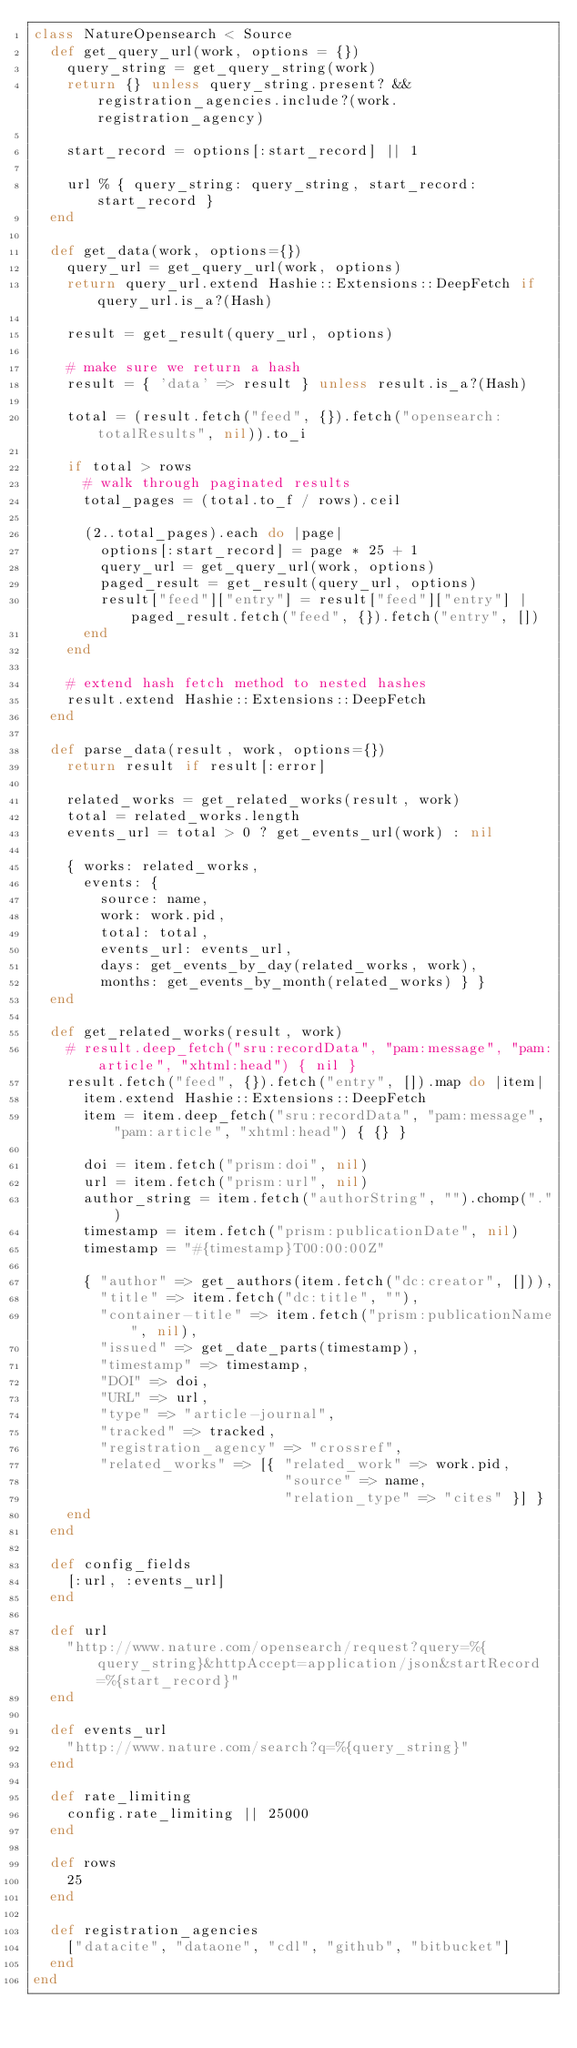Convert code to text. <code><loc_0><loc_0><loc_500><loc_500><_Ruby_>class NatureOpensearch < Source
  def get_query_url(work, options = {})
    query_string = get_query_string(work)
    return {} unless query_string.present? && registration_agencies.include?(work.registration_agency)

    start_record = options[:start_record] || 1

    url % { query_string: query_string, start_record: start_record }
  end

  def get_data(work, options={})
    query_url = get_query_url(work, options)
    return query_url.extend Hashie::Extensions::DeepFetch if query_url.is_a?(Hash)

    result = get_result(query_url, options)

    # make sure we return a hash
    result = { 'data' => result } unless result.is_a?(Hash)

    total = (result.fetch("feed", {}).fetch("opensearch:totalResults", nil)).to_i

    if total > rows
      # walk through paginated results
      total_pages = (total.to_f / rows).ceil

      (2..total_pages).each do |page|
        options[:start_record] = page * 25 + 1
        query_url = get_query_url(work, options)
        paged_result = get_result(query_url, options)
        result["feed"]["entry"] = result["feed"]["entry"] | paged_result.fetch("feed", {}).fetch("entry", [])
      end
    end

    # extend hash fetch method to nested hashes
    result.extend Hashie::Extensions::DeepFetch
  end

  def parse_data(result, work, options={})
    return result if result[:error]

    related_works = get_related_works(result, work)
    total = related_works.length
    events_url = total > 0 ? get_events_url(work) : nil

    { works: related_works,
      events: {
        source: name,
        work: work.pid,
        total: total,
        events_url: events_url,
        days: get_events_by_day(related_works, work),
        months: get_events_by_month(related_works) } }
  end

  def get_related_works(result, work)
    # result.deep_fetch("sru:recordData", "pam:message", "pam:article", "xhtml:head") { nil }
    result.fetch("feed", {}).fetch("entry", []).map do |item|
      item.extend Hashie::Extensions::DeepFetch
      item = item.deep_fetch("sru:recordData", "pam:message", "pam:article", "xhtml:head") { {} }

      doi = item.fetch("prism:doi", nil)
      url = item.fetch("prism:url", nil)
      author_string = item.fetch("authorString", "").chomp(".")
      timestamp = item.fetch("prism:publicationDate", nil)
      timestamp = "#{timestamp}T00:00:00Z"

      { "author" => get_authors(item.fetch("dc:creator", [])),
        "title" => item.fetch("dc:title", ""),
        "container-title" => item.fetch("prism:publicationName", nil),
        "issued" => get_date_parts(timestamp),
        "timestamp" => timestamp,
        "DOI" => doi,
        "URL" => url,
        "type" => "article-journal",
        "tracked" => tracked,
        "registration_agency" => "crossref",
        "related_works" => [{ "related_work" => work.pid,
                              "source" => name,
                              "relation_type" => "cites" }] }
    end
  end

  def config_fields
    [:url, :events_url]
  end

  def url
    "http://www.nature.com/opensearch/request?query=%{query_string}&httpAccept=application/json&startRecord=%{start_record}"
  end

  def events_url
    "http://www.nature.com/search?q=%{query_string}"
  end

  def rate_limiting
    config.rate_limiting || 25000
  end

  def rows
    25
  end

  def registration_agencies
    ["datacite", "dataone", "cdl", "github", "bitbucket"]
  end
end
</code> 